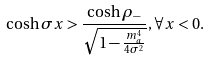<formula> <loc_0><loc_0><loc_500><loc_500>\cosh \sigma x > \frac { \cosh \rho _ { - } } { \sqrt { 1 - \frac { m _ { a } ^ { 4 } } { 4 \sigma ^ { 2 } } } } , \forall x < 0 .</formula> 